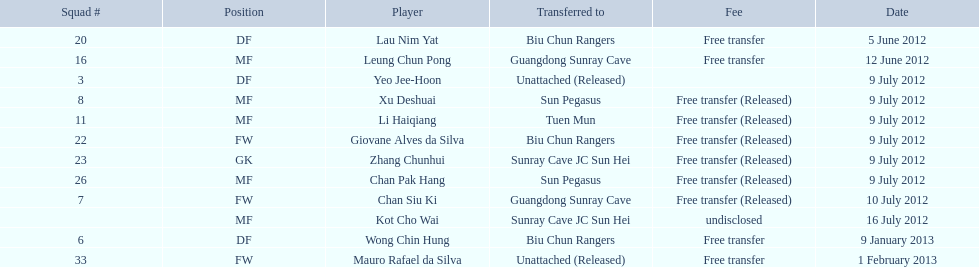For which team did lau nim yat play following his transfer? Biu Chun Rangers. 